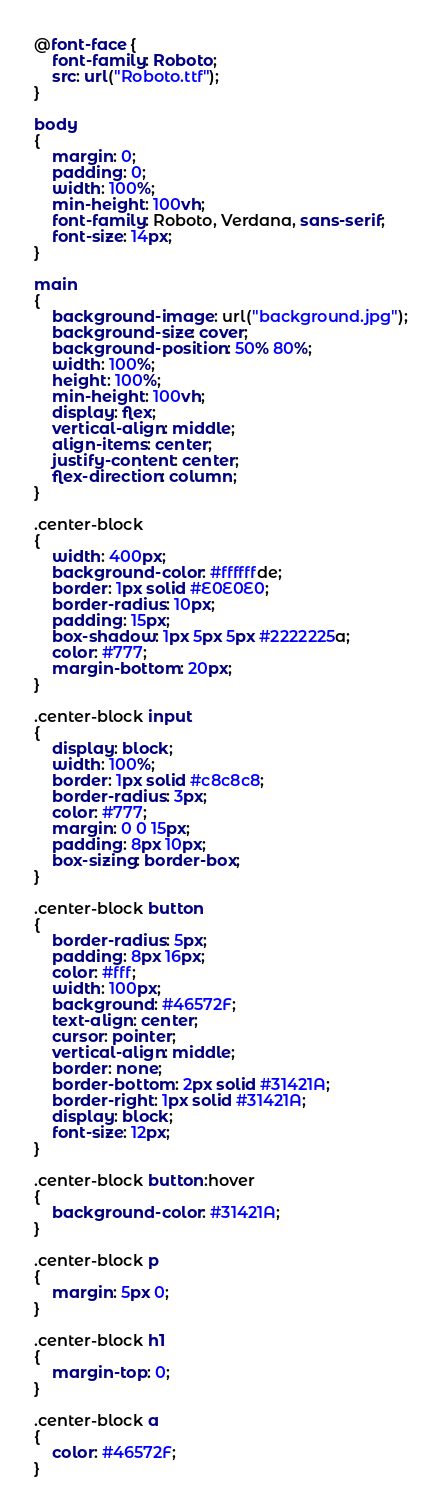<code> <loc_0><loc_0><loc_500><loc_500><_CSS_>@font-face {
    font-family: Roboto;
    src: url("Roboto.ttf");
}

body
{
    margin: 0;
    padding: 0;
    width: 100%;
    min-height: 100vh;
    font-family: Roboto, Verdana, sans-serif;
    font-size: 14px;
}

main
{
    background-image: url("background.jpg");
    background-size: cover;
    background-position: 50% 80%;
    width: 100%;
    height: 100%;
    min-height: 100vh;
    display: flex;
    vertical-align: middle;
    align-items: center;
    justify-content: center;
    flex-direction: column;
}

.center-block
{
    width: 400px;
    background-color: #ffffffde;
    border: 1px solid #E0E0E0;
    border-radius: 10px;
    padding: 15px;
    box-shadow: 1px 5px 5px #2222225a;
    color: #777;
    margin-bottom: 20px;
}

.center-block input
{
    display: block;
    width: 100%;
    border: 1px solid #c8c8c8;
    border-radius: 3px;
    color: #777;
    margin: 0 0 15px;
    padding: 8px 10px;
    box-sizing: border-box;
}

.center-block button 
{
    border-radius: 5px;
    padding: 8px 16px;
    color: #fff;
    width: 100px;
    background: #46572F;
    text-align: center;
    cursor: pointer;
    vertical-align: middle;
    border: none;
    border-bottom: 2px solid #31421A;
    border-right: 1px solid #31421A;
    display: block;
    font-size: 12px;
}

.center-block button:hover 
{
    background-color: #31421A;   
}

.center-block p
{
    margin: 5px 0;
}

.center-block h1
{
    margin-top: 0;
}

.center-block a
{
    color: #46572F;
}</code> 